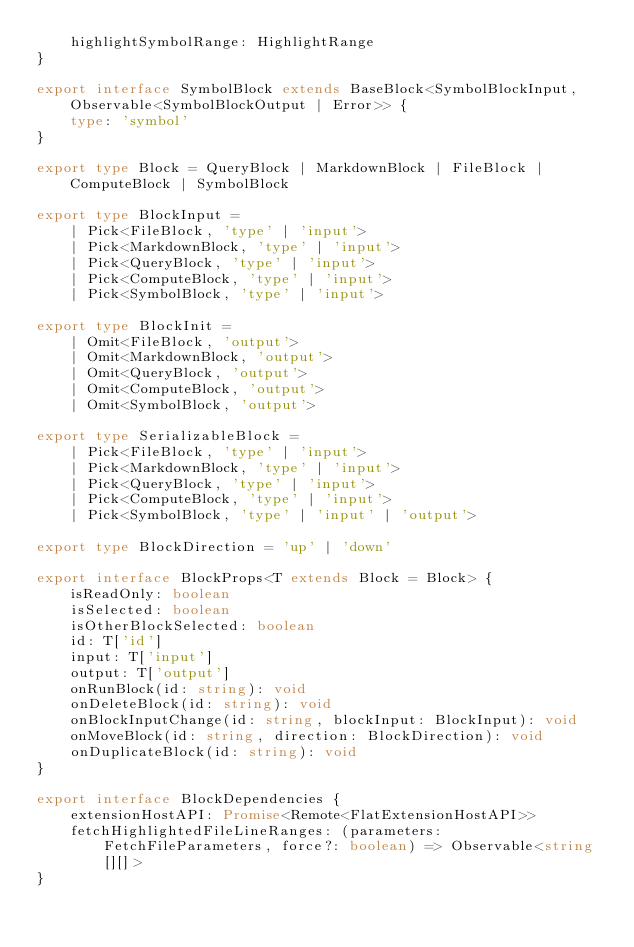<code> <loc_0><loc_0><loc_500><loc_500><_TypeScript_>    highlightSymbolRange: HighlightRange
}

export interface SymbolBlock extends BaseBlock<SymbolBlockInput, Observable<SymbolBlockOutput | Error>> {
    type: 'symbol'
}

export type Block = QueryBlock | MarkdownBlock | FileBlock | ComputeBlock | SymbolBlock

export type BlockInput =
    | Pick<FileBlock, 'type' | 'input'>
    | Pick<MarkdownBlock, 'type' | 'input'>
    | Pick<QueryBlock, 'type' | 'input'>
    | Pick<ComputeBlock, 'type' | 'input'>
    | Pick<SymbolBlock, 'type' | 'input'>

export type BlockInit =
    | Omit<FileBlock, 'output'>
    | Omit<MarkdownBlock, 'output'>
    | Omit<QueryBlock, 'output'>
    | Omit<ComputeBlock, 'output'>
    | Omit<SymbolBlock, 'output'>

export type SerializableBlock =
    | Pick<FileBlock, 'type' | 'input'>
    | Pick<MarkdownBlock, 'type' | 'input'>
    | Pick<QueryBlock, 'type' | 'input'>
    | Pick<ComputeBlock, 'type' | 'input'>
    | Pick<SymbolBlock, 'type' | 'input' | 'output'>

export type BlockDirection = 'up' | 'down'

export interface BlockProps<T extends Block = Block> {
    isReadOnly: boolean
    isSelected: boolean
    isOtherBlockSelected: boolean
    id: T['id']
    input: T['input']
    output: T['output']
    onRunBlock(id: string): void
    onDeleteBlock(id: string): void
    onBlockInputChange(id: string, blockInput: BlockInput): void
    onMoveBlock(id: string, direction: BlockDirection): void
    onDuplicateBlock(id: string): void
}

export interface BlockDependencies {
    extensionHostAPI: Promise<Remote<FlatExtensionHostAPI>>
    fetchHighlightedFileLineRanges: (parameters: FetchFileParameters, force?: boolean) => Observable<string[][]>
}
</code> 